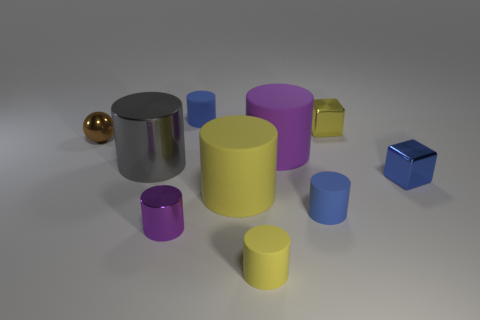There is a shiny thing that is to the left of the purple shiny cylinder and behind the gray metal object; what size is it?
Provide a succinct answer. Small. How many tiny things are purple cylinders or purple rubber cylinders?
Your answer should be compact. 1. There is a small metallic object that is on the right side of the small yellow metal cube; what is its shape?
Your answer should be compact. Cube. What number of matte cylinders are there?
Give a very brief answer. 5. Do the tiny purple cylinder and the tiny blue block have the same material?
Your answer should be compact. Yes. Are there more yellow rubber cylinders that are behind the tiny sphere than tiny yellow cylinders?
Your answer should be compact. No. How many things are blue rubber cylinders or metallic cylinders that are to the right of the gray metal cylinder?
Offer a very short reply. 3. Are there more brown things in front of the gray metallic cylinder than blue metallic blocks to the left of the small yellow cylinder?
Give a very brief answer. No. What material is the blue cylinder that is behind the gray shiny cylinder in front of the large rubber thing right of the big yellow object made of?
Your answer should be very brief. Rubber. There is a large yellow thing that is made of the same material as the big purple thing; what is its shape?
Your response must be concise. Cylinder. 